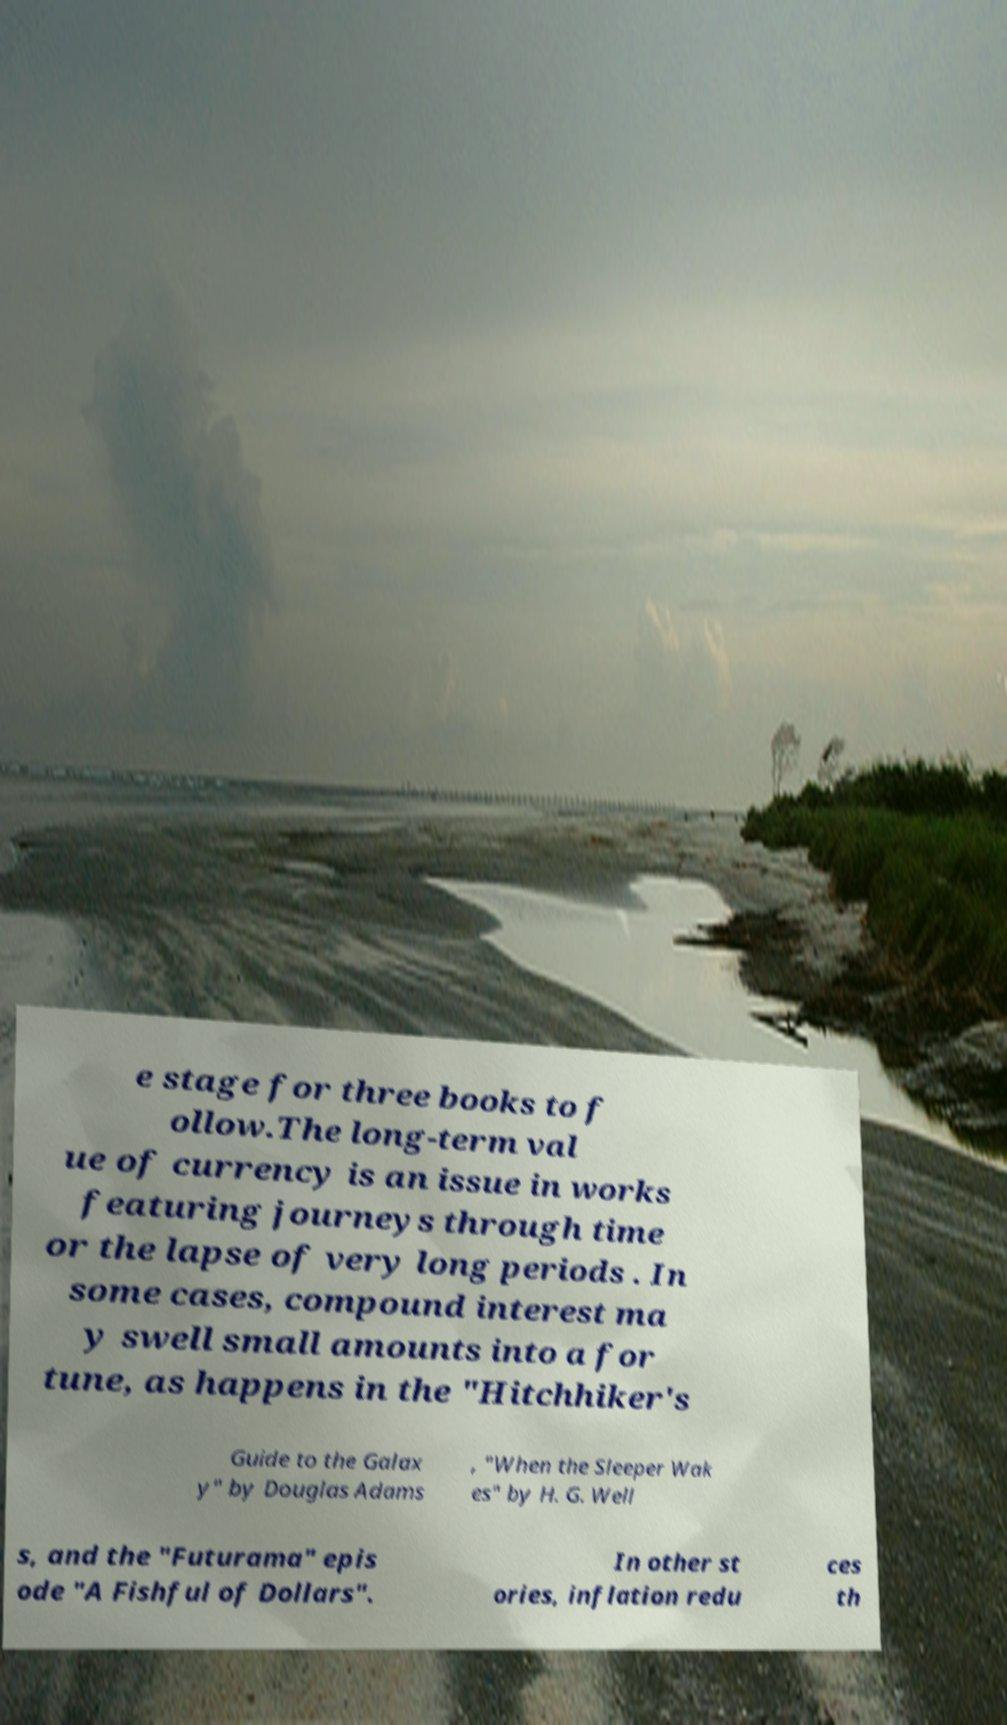Can you accurately transcribe the text from the provided image for me? e stage for three books to f ollow.The long-term val ue of currency is an issue in works featuring journeys through time or the lapse of very long periods . In some cases, compound interest ma y swell small amounts into a for tune, as happens in the "Hitchhiker's Guide to the Galax y" by Douglas Adams , "When the Sleeper Wak es" by H. G. Well s, and the "Futurama" epis ode "A Fishful of Dollars". In other st ories, inflation redu ces th 